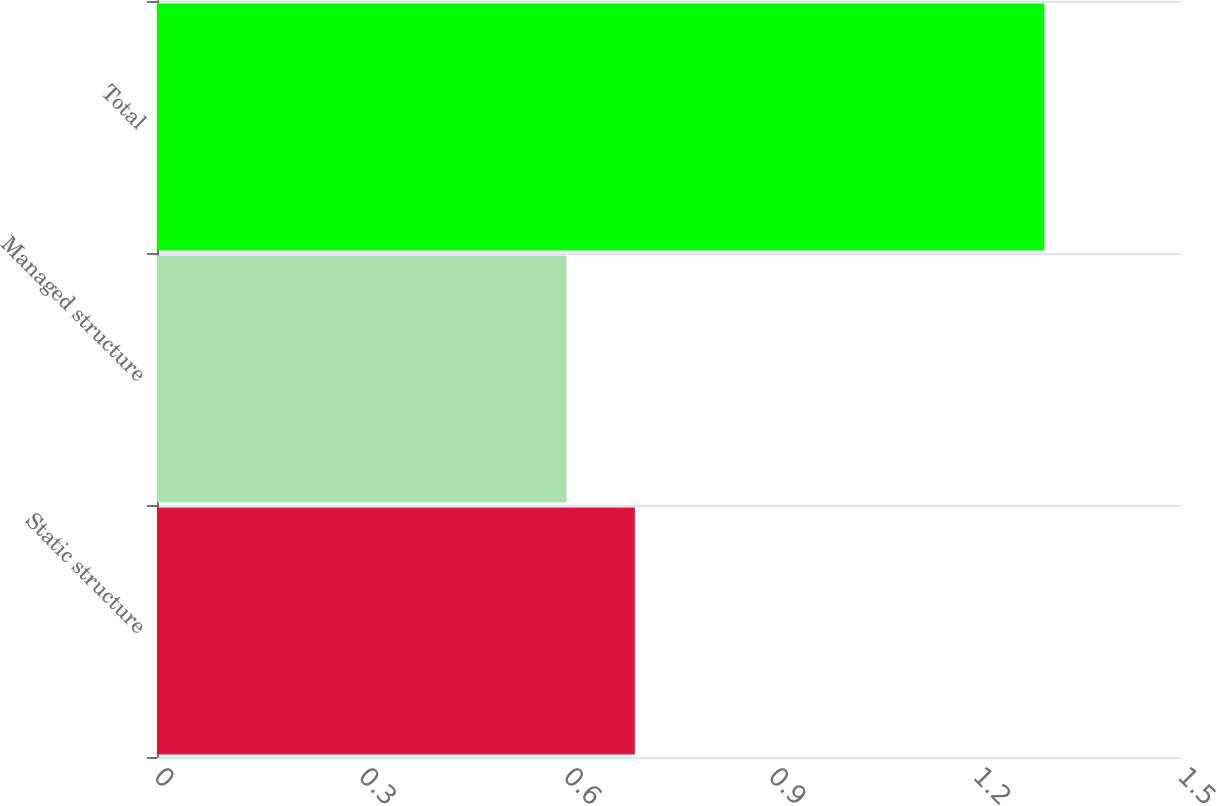Convert chart to OTSL. <chart><loc_0><loc_0><loc_500><loc_500><bar_chart><fcel>Static structure<fcel>Managed structure<fcel>Total<nl><fcel>0.7<fcel>0.6<fcel>1.3<nl></chart> 